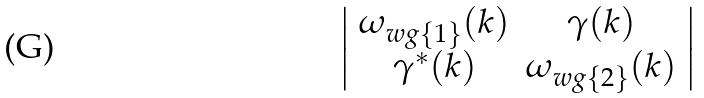<formula> <loc_0><loc_0><loc_500><loc_500>\left | { \begin{array} { c c } \omega _ { w g \{ 1 \} } ( k ) & \gamma ( k ) \\ { \gamma } ^ { * } ( k ) & \omega _ { w g \{ 2 \} } ( k ) \\ \end{array} } \right |</formula> 